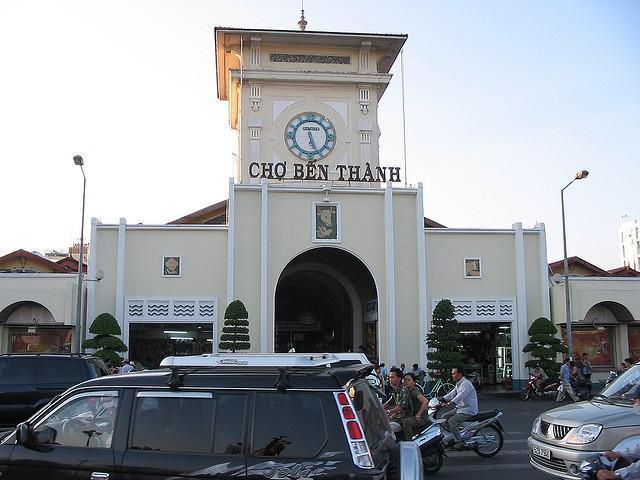Judging from the signage beneath the clock where is this structure located?
Indicate the correct response and explain using: 'Answer: answer
Rationale: rationale.'
Options: India, south america, europe, asia. Answer: asia.
Rationale: The letters on the sign look like their are from the thai alphabet in asia. 